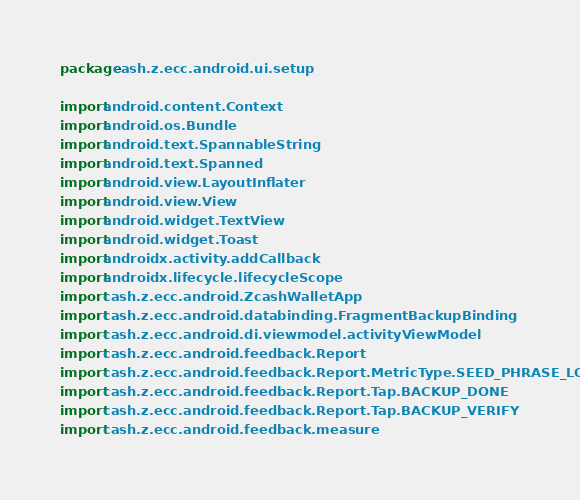Convert code to text. <code><loc_0><loc_0><loc_500><loc_500><_Kotlin_>package cash.z.ecc.android.ui.setup

import android.content.Context
import android.os.Bundle
import android.text.SpannableString
import android.text.Spanned
import android.view.LayoutInflater
import android.view.View
import android.widget.TextView
import android.widget.Toast
import androidx.activity.addCallback
import androidx.lifecycle.lifecycleScope
import cash.z.ecc.android.ZcashWalletApp
import cash.z.ecc.android.databinding.FragmentBackupBinding
import cash.z.ecc.android.di.viewmodel.activityViewModel
import cash.z.ecc.android.feedback.Report
import cash.z.ecc.android.feedback.Report.MetricType.SEED_PHRASE_LOADED
import cash.z.ecc.android.feedback.Report.Tap.BACKUP_DONE
import cash.z.ecc.android.feedback.Report.Tap.BACKUP_VERIFY
import cash.z.ecc.android.feedback.measure</code> 